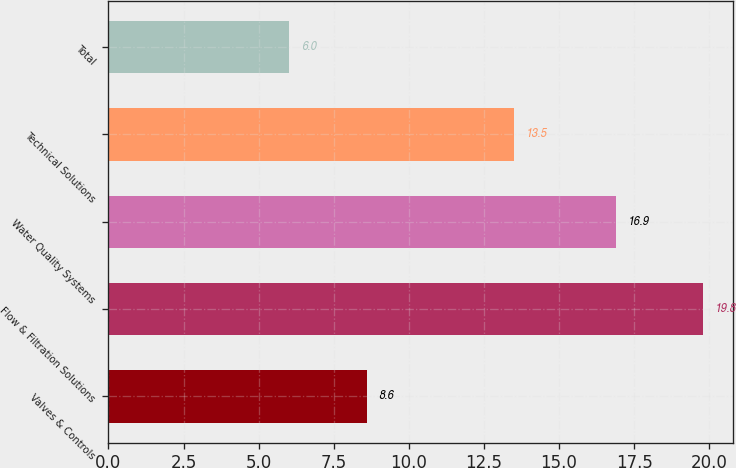<chart> <loc_0><loc_0><loc_500><loc_500><bar_chart><fcel>Valves & Controls<fcel>Flow & Filtration Solutions<fcel>Water Quality Systems<fcel>Technical Solutions<fcel>Total<nl><fcel>8.6<fcel>19.8<fcel>16.9<fcel>13.5<fcel>6<nl></chart> 